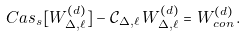Convert formula to latex. <formula><loc_0><loc_0><loc_500><loc_500>C a s _ { s } [ W ^ { ( d ) } _ { \Delta , \ell } ] - \mathcal { C } _ { \Delta , \ell } \, W ^ { ( d ) } _ { \Delta , \ell } = W ^ { ( d ) } _ { c o n } \, .</formula> 